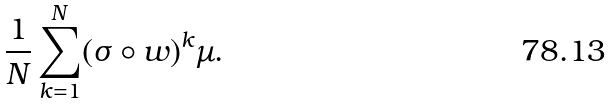Convert formula to latex. <formula><loc_0><loc_0><loc_500><loc_500>\frac { 1 } { N } \sum _ { k = 1 } ^ { N } ( \sigma \circ w ) ^ { k } \mu .</formula> 